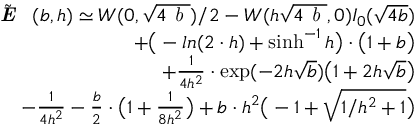<formula> <loc_0><loc_0><loc_500><loc_500>\begin{array} { r l r } & { \tilde { \emph { E } } ( b , h ) \simeq W ( 0 , \sqrt { 4 \emph { b } } ) / 2 - W ( h \sqrt { 4 \emph { b } } , 0 ) I _ { 0 } ( \sqrt { 4 b } ) } \\ & { + \left ( - \ln ( 2 \cdot h ) + \sinh ^ { - 1 } { h } \right ) \cdot \left ( 1 + b \right ) } \\ & { + { \frac { 1 } { 4 h ^ { 2 } } } \cdot \exp ( - 2 h \sqrt { b } ) \left ( 1 + 2 h \sqrt { b } \right ) } \\ & { - { \frac { 1 } { 4 h ^ { 2 } } } - { \frac { b } { 2 } } \cdot \left ( 1 + { \frac { 1 } { 8 h ^ { 2 } } } \right ) + b \cdot h ^ { 2 } \left ( - 1 + \sqrt { 1 / h ^ { 2 } + 1 } \right ) } \end{array}</formula> 